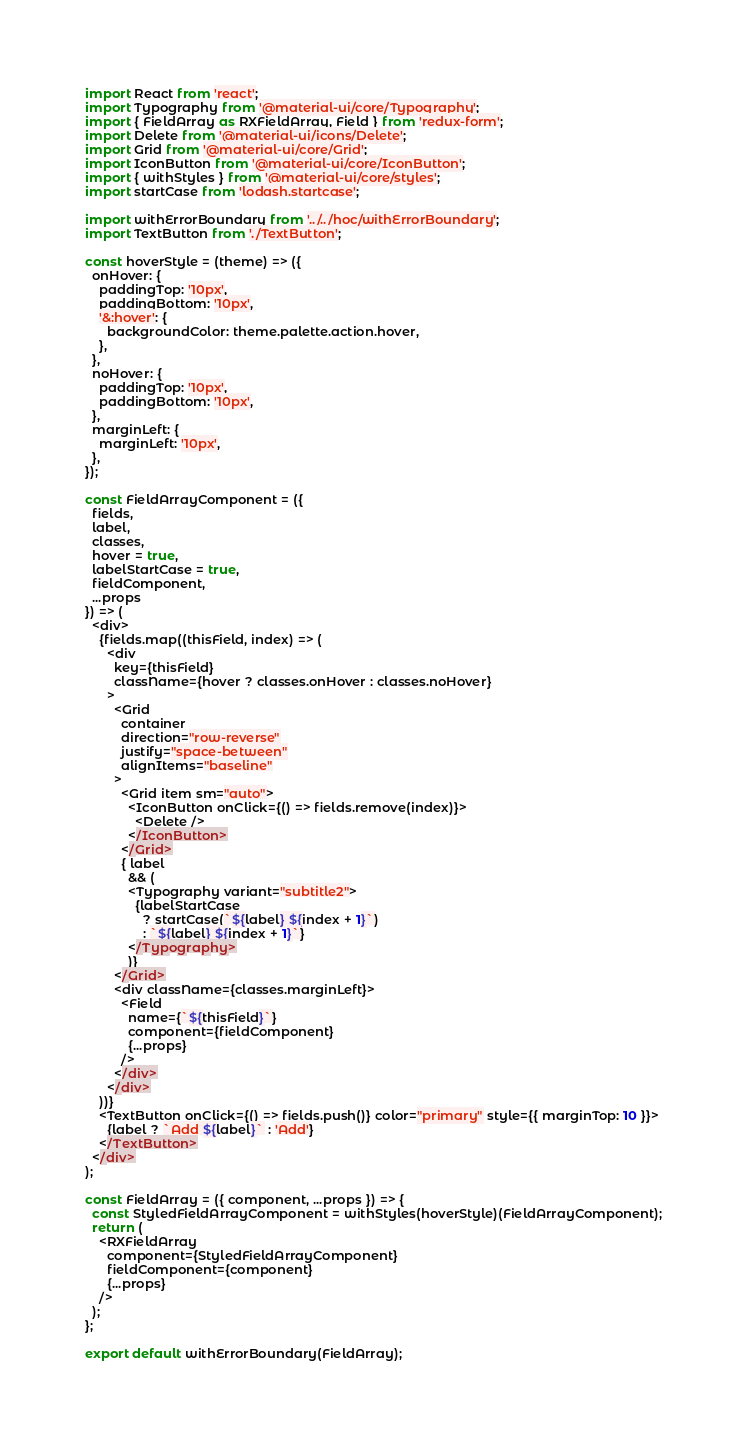Convert code to text. <code><loc_0><loc_0><loc_500><loc_500><_JavaScript_>import React from 'react';
import Typography from '@material-ui/core/Typography';
import { FieldArray as RXFieldArray, Field } from 'redux-form';
import Delete from '@material-ui/icons/Delete';
import Grid from '@material-ui/core/Grid';
import IconButton from '@material-ui/core/IconButton';
import { withStyles } from '@material-ui/core/styles';
import startCase from 'lodash.startcase';

import withErrorBoundary from '../../hoc/withErrorBoundary';
import TextButton from './TextButton';

const hoverStyle = (theme) => ({
  onHover: {
    paddingTop: '10px',
    paddingBottom: '10px',
    '&:hover': {
      backgroundColor: theme.palette.action.hover,
    },
  },
  noHover: {
    paddingTop: '10px',
    paddingBottom: '10px',
  },
  marginLeft: {
    marginLeft: '10px',
  },
});

const FieldArrayComponent = ({
  fields,
  label,
  classes,
  hover = true,
  labelStartCase = true,
  fieldComponent,
  ...props
}) => (
  <div>
    {fields.map((thisField, index) => (
      <div
        key={thisField}
        className={hover ? classes.onHover : classes.noHover}
      >
        <Grid
          container
          direction="row-reverse"
          justify="space-between"
          alignItems="baseline"
        >
          <Grid item sm="auto">
            <IconButton onClick={() => fields.remove(index)}>
              <Delete />
            </IconButton>
          </Grid>
          { label
            && (
            <Typography variant="subtitle2">
              {labelStartCase
                ? startCase(`${label} ${index + 1}`)
                : `${label} ${index + 1}`}
            </Typography>
            )}
        </Grid>
        <div className={classes.marginLeft}>
          <Field
            name={`${thisField}`}
            component={fieldComponent}
            {...props}
          />
        </div>
      </div>
    ))}
    <TextButton onClick={() => fields.push()} color="primary" style={{ marginTop: 10 }}>
      {label ? `Add ${label}` : 'Add'}
    </TextButton>
  </div>
);

const FieldArray = ({ component, ...props }) => {
  const StyledFieldArrayComponent = withStyles(hoverStyle)(FieldArrayComponent);
  return (
    <RXFieldArray
      component={StyledFieldArrayComponent}
      fieldComponent={component}
      {...props}
    />
  );
};

export default withErrorBoundary(FieldArray);
</code> 